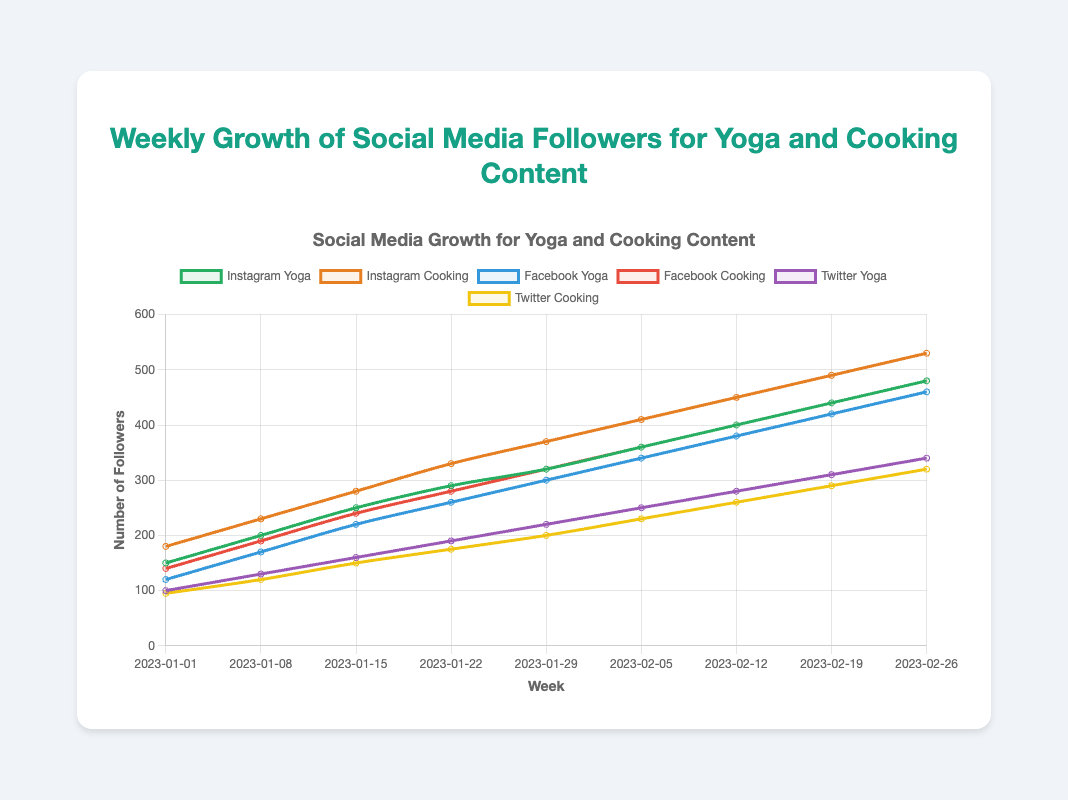Which social media platform has the highest number of yoga followers during the last recorded week? On the week of 2023-02-26, Instagram, Facebook, and Twitter platforms' follower counts for yoga are shown as 480, 460, and 340, respectively. Among these, Instagram has the highest number of yoga followers.
Answer: Instagram By how much did the Instagram cooking followers increase from the first to the last recorded week? The Instagram cooking followers were 180 on 2023-01-01 and increased to 530 by 2023-02-26. The difference is 530 - 180 = 350.
Answer: 350 Which content type has shown more growth on Twitter, yoga or cooking? By looking at Twitter followers on 2023-01-01 and 2023-02-26, yoga followers grew from 100 to 340, an increase of 240. Cooking followers grew from 95 to 320, an increase of 225. Yoga content showed more growth.
Answer: Yoga In which week did Instagram cooking followers surpass 300? Observing the Instagram cooking followers over time, it surpassed 300 in the week of 2023-01-22 where it reached 330 followers.
Answer: 2023-01-22 What is the combined total number of Facebook yoga and Facebook cooking followers on the week of 2023-02-12? For the week of 2023-02-12, the Facebook yoga followers are 380 and the Facebook cooking followers are 400. The total is 380 + 400 = 780.
Answer: 780 Which week shows the smallest increase in Twitter yoga followers compared to the previous week? If we examine week-by-week increases in Twitter yoga followers, we see the smallest increase between 2023-01-22 (190) and 2023-01-29 (220), which is 220 - 190 = 30.
Answer: 2023-01-29 By examining the growth trends, which social media platform showed the most consistent increase for cooking content? Inspecting the charts for each platform over weeks, Instagram cooking followers show a steady, consistent increase with no dips or anomalies in the follower counts.
Answer: Instagram What is the average number of Instagram yoga followers over the 8-week period starting from 2023-01-01 to 2023-02-26? The Instagram yoga followers count for each week over this period are:
150, 200, 250, 290, 320, 360, 400, 440, 480. Summing them up gives 2890 followers across 8 weeks. 
Therefore, the average is 2890 / 8 = 361.25.
Answer: 361.25 